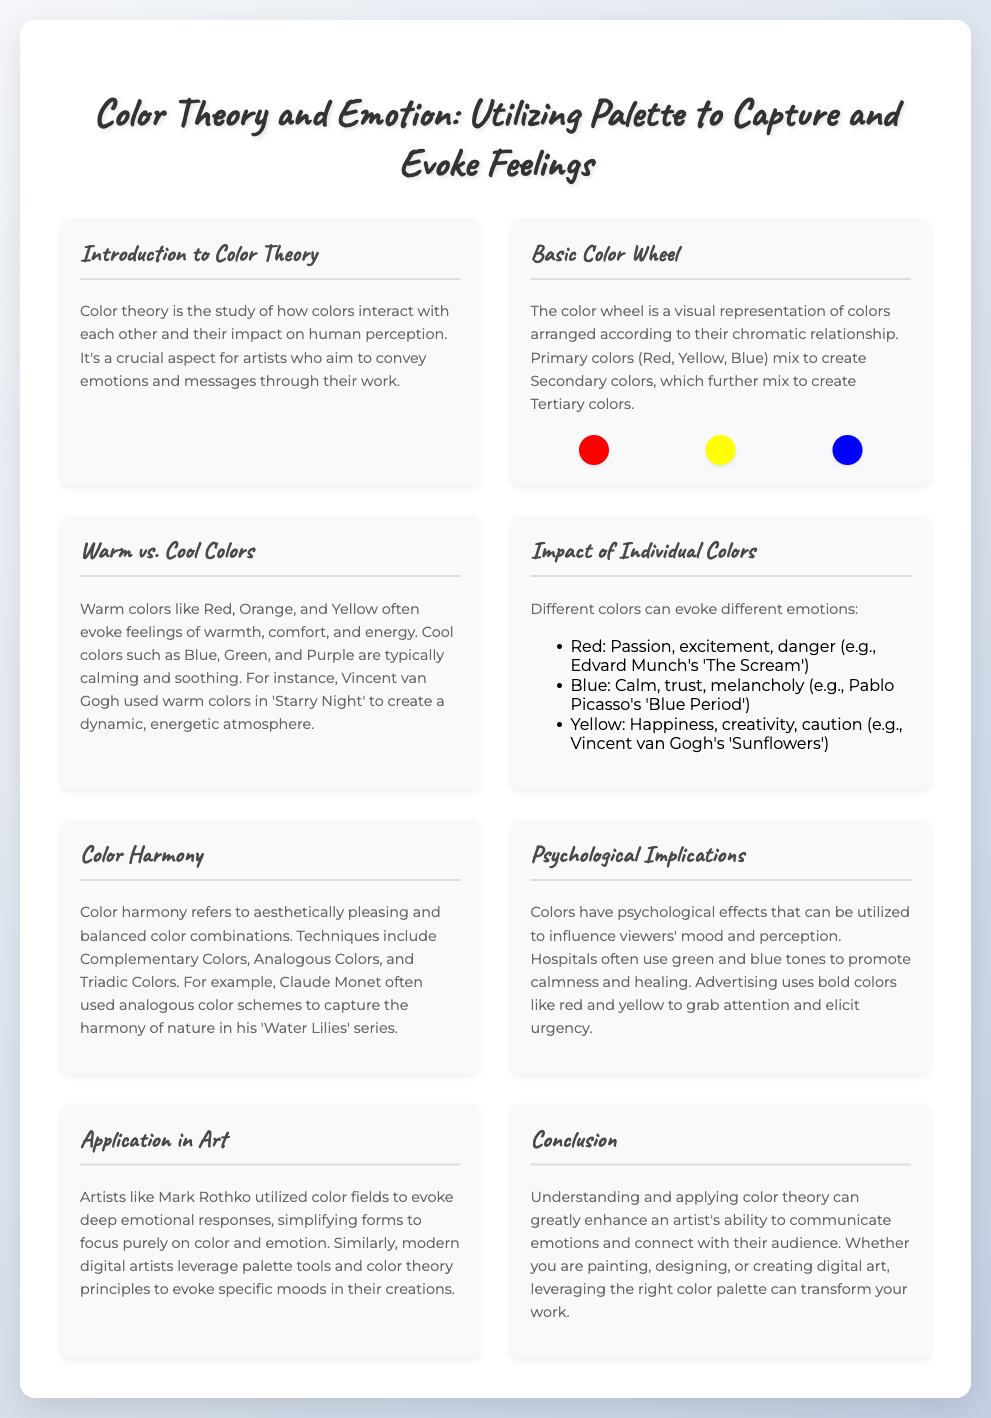What is the title of the presentation? The title of the presentation is the heading displayed at the top of the slide.
Answer: Color Theory and Emotion: Utilizing Palette to Capture and Evoke Feelings What are the primary colors? The primary colors are explicitly mentioned in the section about the basic color wheel.
Answer: Red, Yellow, Blue Which artist is mentioned in relation to 'Starry Night'? The artist associated with 'Starry Night' is mentioned in the section about warm and cool colors.
Answer: Vincent van Gogh What emotional response does Red evoke? The emotional response related to Red is provided in the impact of individual colors section.
Answer: Passion, excitement, danger What color scheme does Claude Monet often use? Claude Monet's color scheme preference is stated in the color harmony section.
Answer: Analogous color schemes What is color harmony? The definition is given in the color harmony section, describing its aesthetic quality.
Answer: Aesthetically pleasing and balanced color combinations Which colors promote calmness and healing? The colors used to promote calmness and healing are mentioned in the psychological implications section.
Answer: Green and blue tones What aspect of art do Mark Rothko's works emphasize? The focus of Rothko's works is detailed in the application in art section.
Answer: Color and emotion 